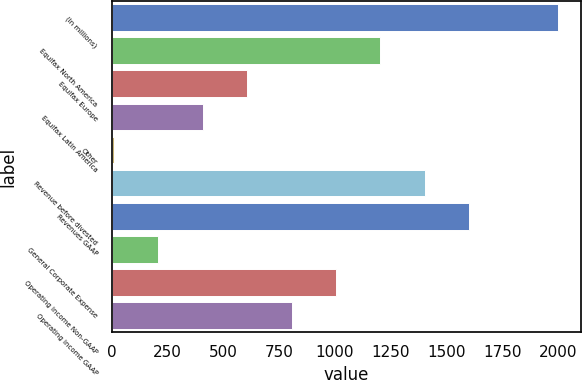Convert chart to OTSL. <chart><loc_0><loc_0><loc_500><loc_500><bar_chart><fcel>(In millions)<fcel>Equifax North America<fcel>Equifax Europe<fcel>Equifax Latin America<fcel>Other<fcel>Revenue before divested<fcel>Revenues GAAP<fcel>General Corporate Expense<fcel>Operating income Non-GAAP<fcel>Operating income GAAP<nl><fcel>2000<fcel>1203.84<fcel>606.72<fcel>407.68<fcel>9.6<fcel>1402.88<fcel>1601.92<fcel>208.64<fcel>1004.8<fcel>805.76<nl></chart> 